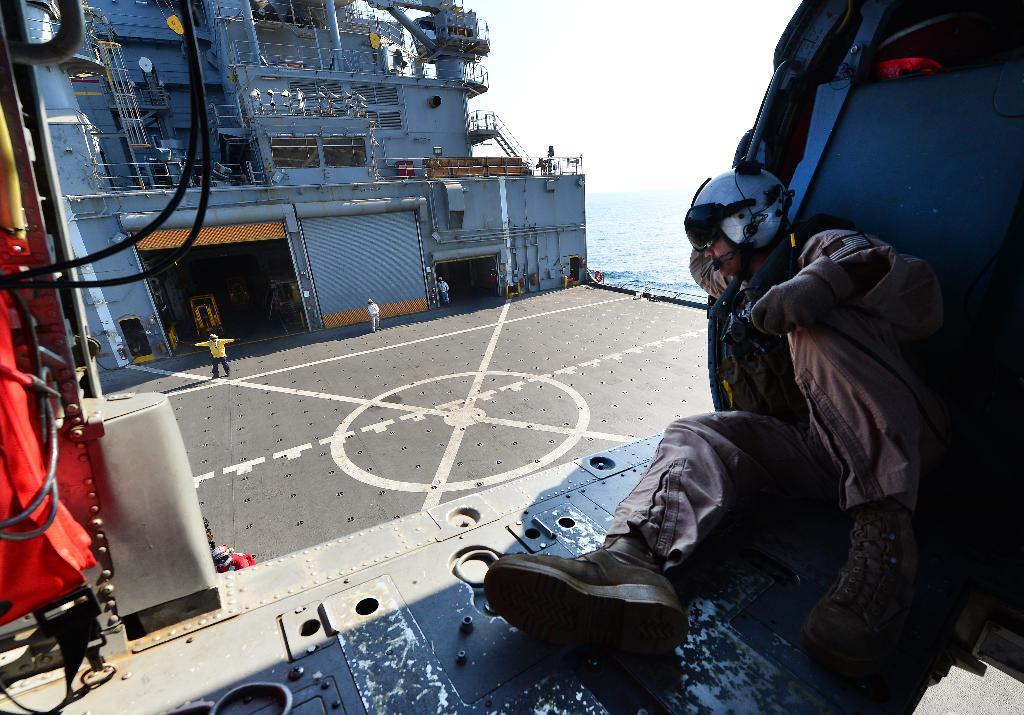Could you give a brief overview of what you see in this image? In this image we can see this person wearing jacket, helmet and shoes is sitting here and these people are standing here, we can see pipes and the ship which is floating on the water. In the background, we can see the sky. 